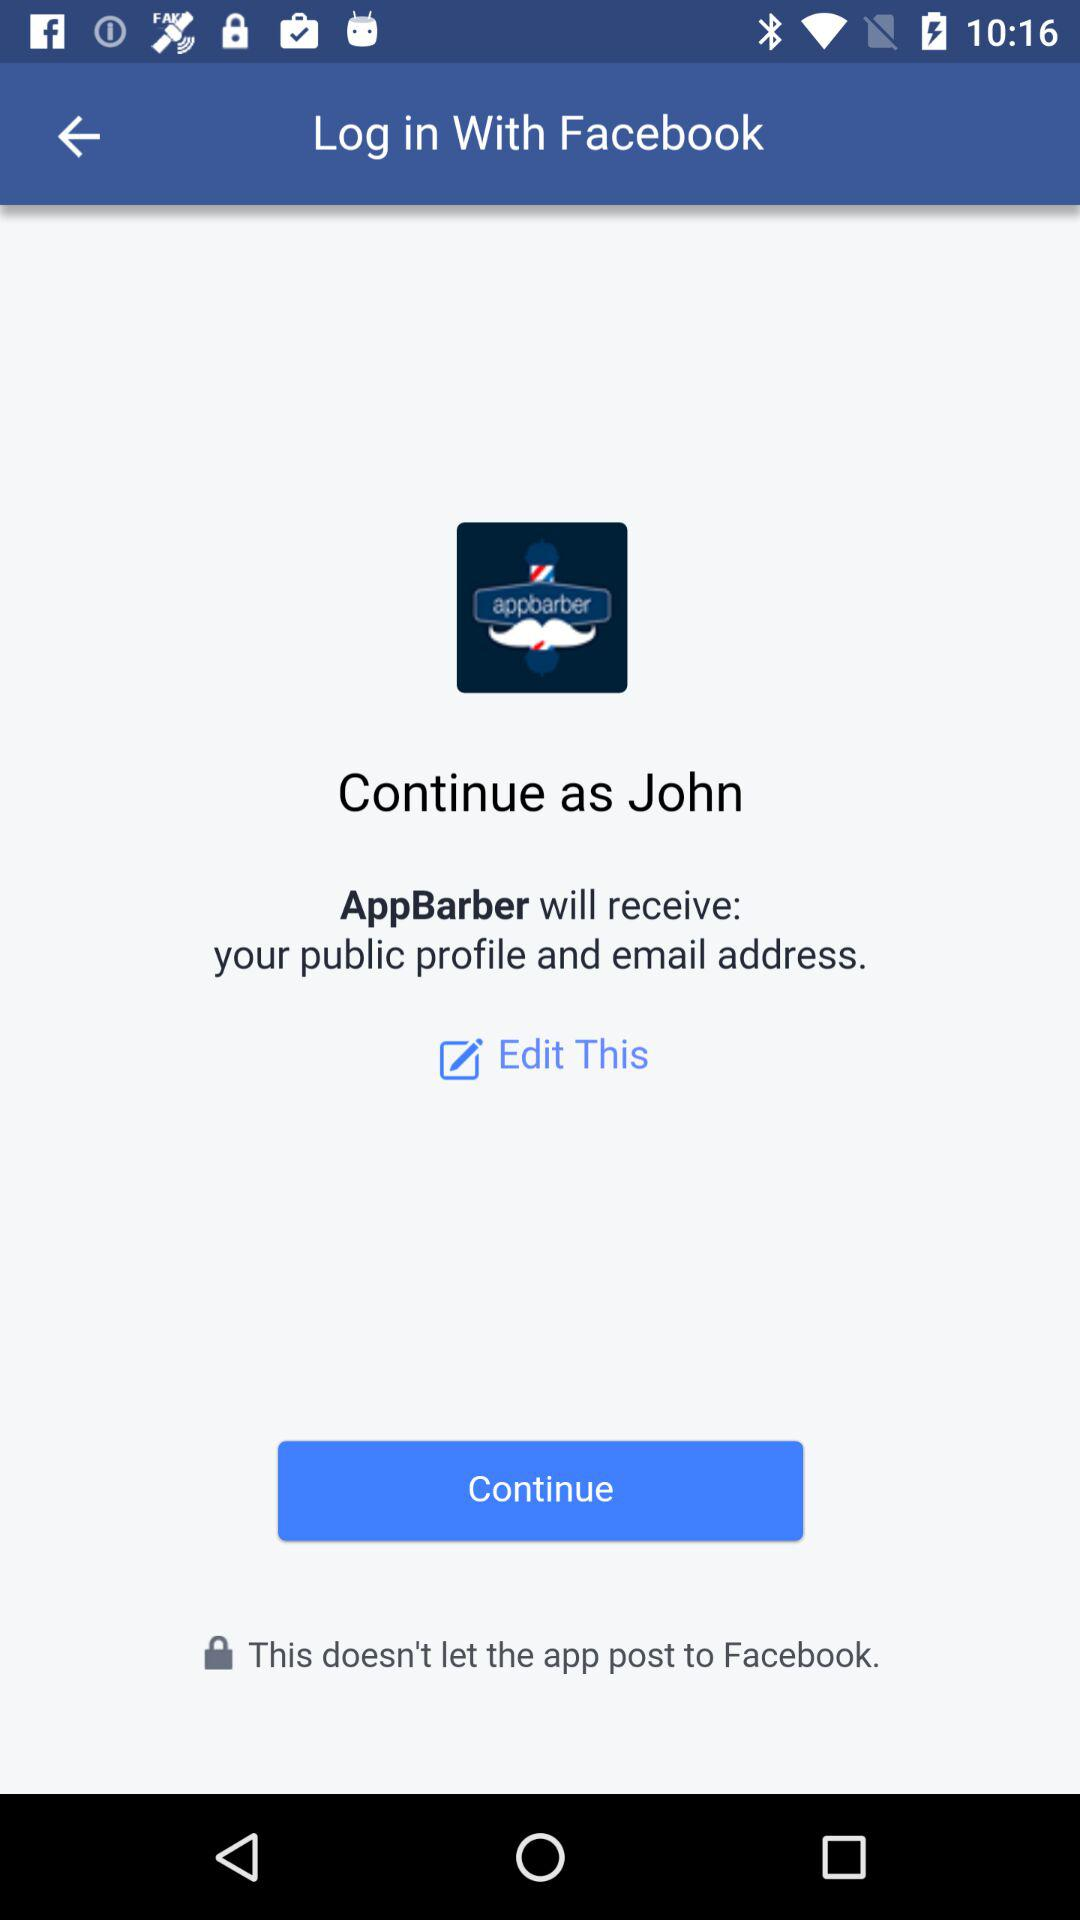What application is asking for permission? The application that is asking for permission is "AppBarber". 